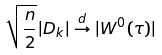Convert formula to latex. <formula><loc_0><loc_0><loc_500><loc_500>\sqrt { \frac { n } { 2 } } | D _ { k } | \stackrel { d } { \to } | W ^ { 0 } ( \tau ) |</formula> 